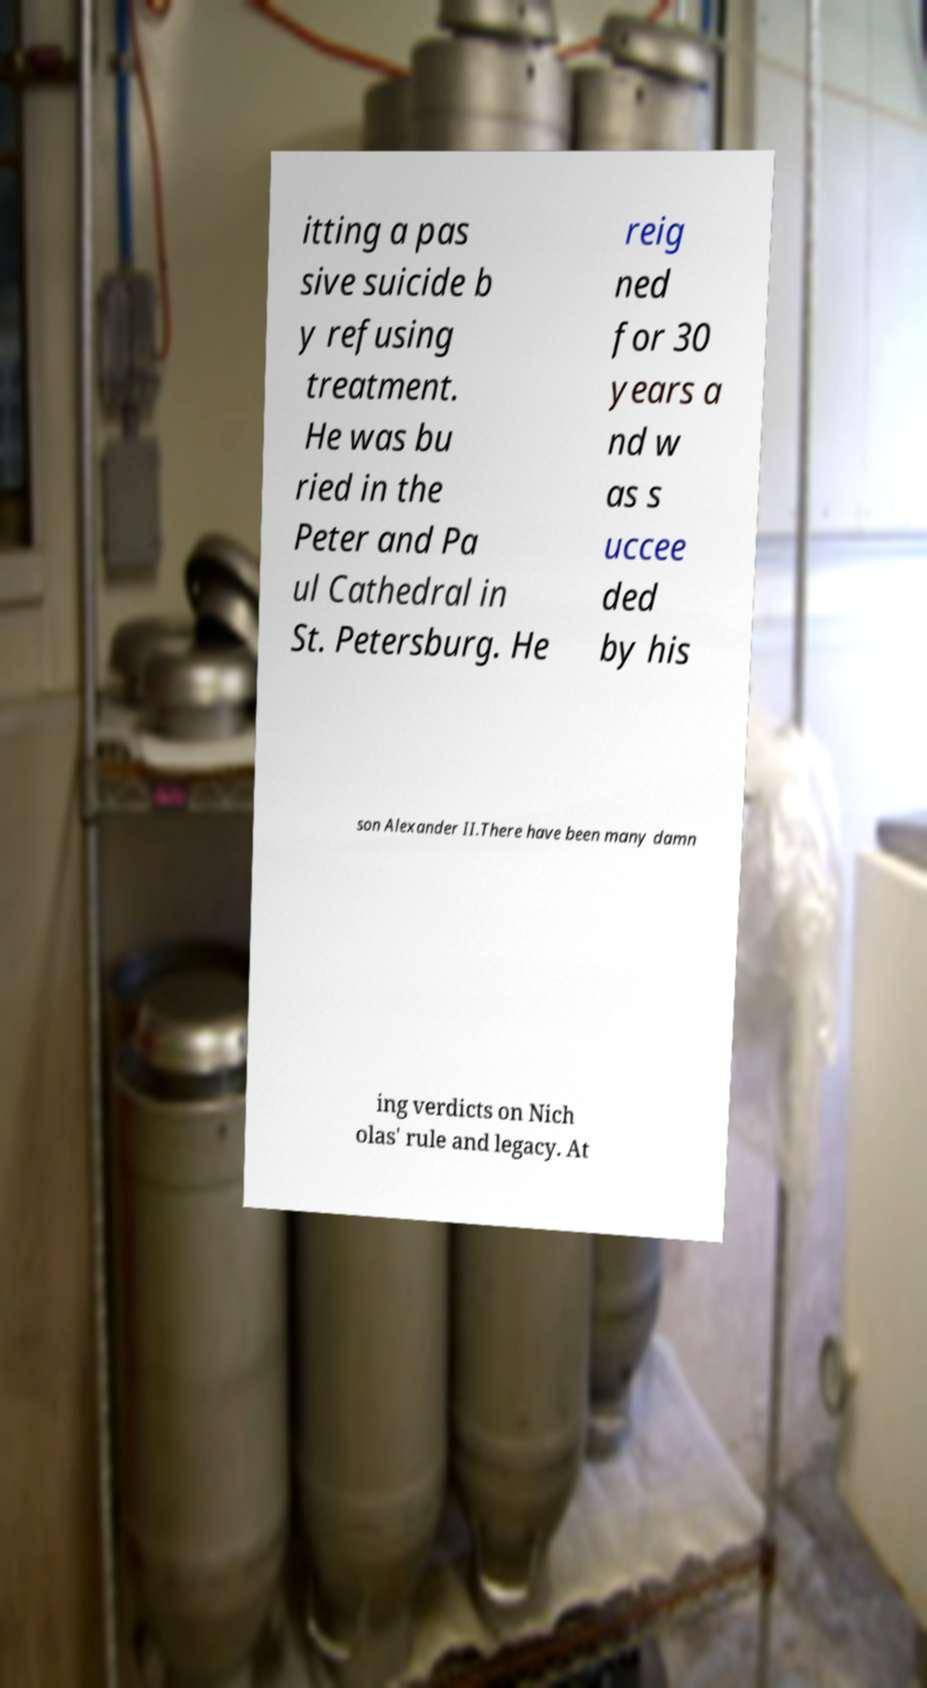There's text embedded in this image that I need extracted. Can you transcribe it verbatim? itting a pas sive suicide b y refusing treatment. He was bu ried in the Peter and Pa ul Cathedral in St. Petersburg. He reig ned for 30 years a nd w as s uccee ded by his son Alexander II.There have been many damn ing verdicts on Nich olas' rule and legacy. At 